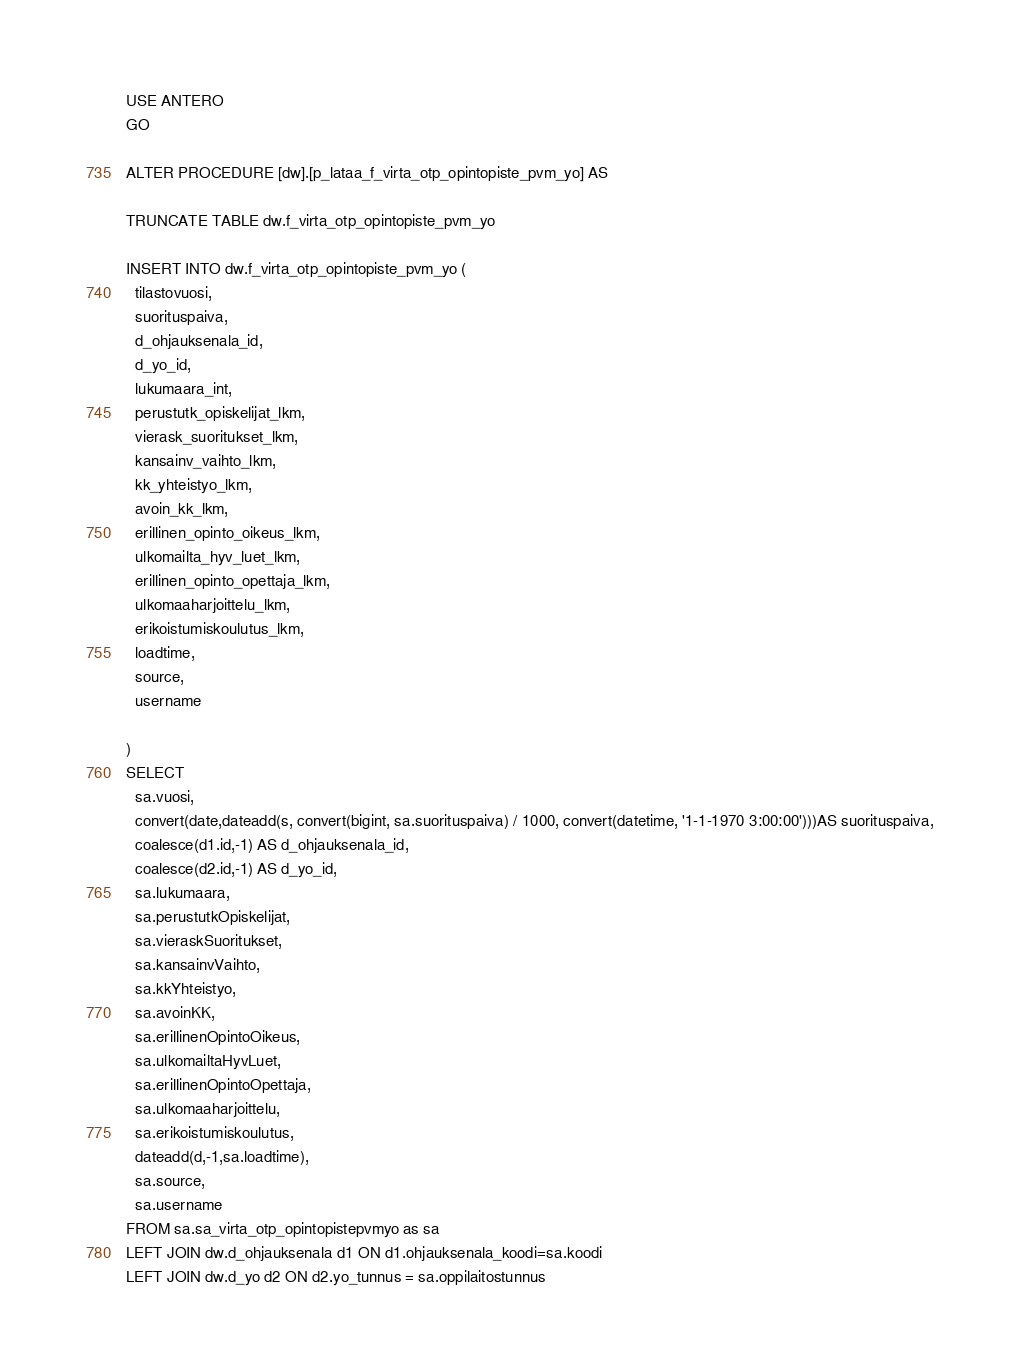<code> <loc_0><loc_0><loc_500><loc_500><_SQL_>USE ANTERO
GO

ALTER PROCEDURE [dw].[p_lataa_f_virta_otp_opintopiste_pvm_yo] AS 

TRUNCATE TABLE dw.f_virta_otp_opintopiste_pvm_yo

INSERT INTO dw.f_virta_otp_opintopiste_pvm_yo (
  tilastovuosi,
  suorituspaiva,
  d_ohjauksenala_id,
  d_yo_id,
  lukumaara_int,
  perustutk_opiskelijat_lkm,
  vierask_suoritukset_lkm,
  kansainv_vaihto_lkm,
  kk_yhteistyo_lkm,
  avoin_kk_lkm,
  erillinen_opinto_oikeus_lkm,
  ulkomailta_hyv_luet_lkm,
  erillinen_opinto_opettaja_lkm,
  ulkomaaharjoittelu_lkm,
  erikoistumiskoulutus_lkm,
  loadtime,
  source,
  username
  
)
SELECT
  sa.vuosi,
  convert(date,dateadd(s, convert(bigint, sa.suorituspaiva) / 1000, convert(datetime, '1-1-1970 3:00:00')))AS suorituspaiva,
  coalesce(d1.id,-1) AS d_ohjauksenala_id,
  coalesce(d2.id,-1) AS d_yo_id,
  sa.lukumaara,
  sa.perustutkOpiskelijat,
  sa.vieraskSuoritukset,
  sa.kansainvVaihto,
  sa.kkYhteistyo,
  sa.avoinKK,
  sa.erillinenOpintoOikeus,
  sa.ulkomailtaHyvLuet,
  sa.erillinenOpintoOpettaja,
  sa.ulkomaaharjoittelu,
  sa.erikoistumiskoulutus, 
  dateadd(d,-1,sa.loadtime),
  sa.source,
  sa.username
FROM sa.sa_virta_otp_opintopistepvmyo as sa
LEFT JOIN dw.d_ohjauksenala d1 ON d1.ohjauksenala_koodi=sa.koodi
LEFT JOIN dw.d_yo d2 ON d2.yo_tunnus = sa.oppilaitostunnus


</code> 